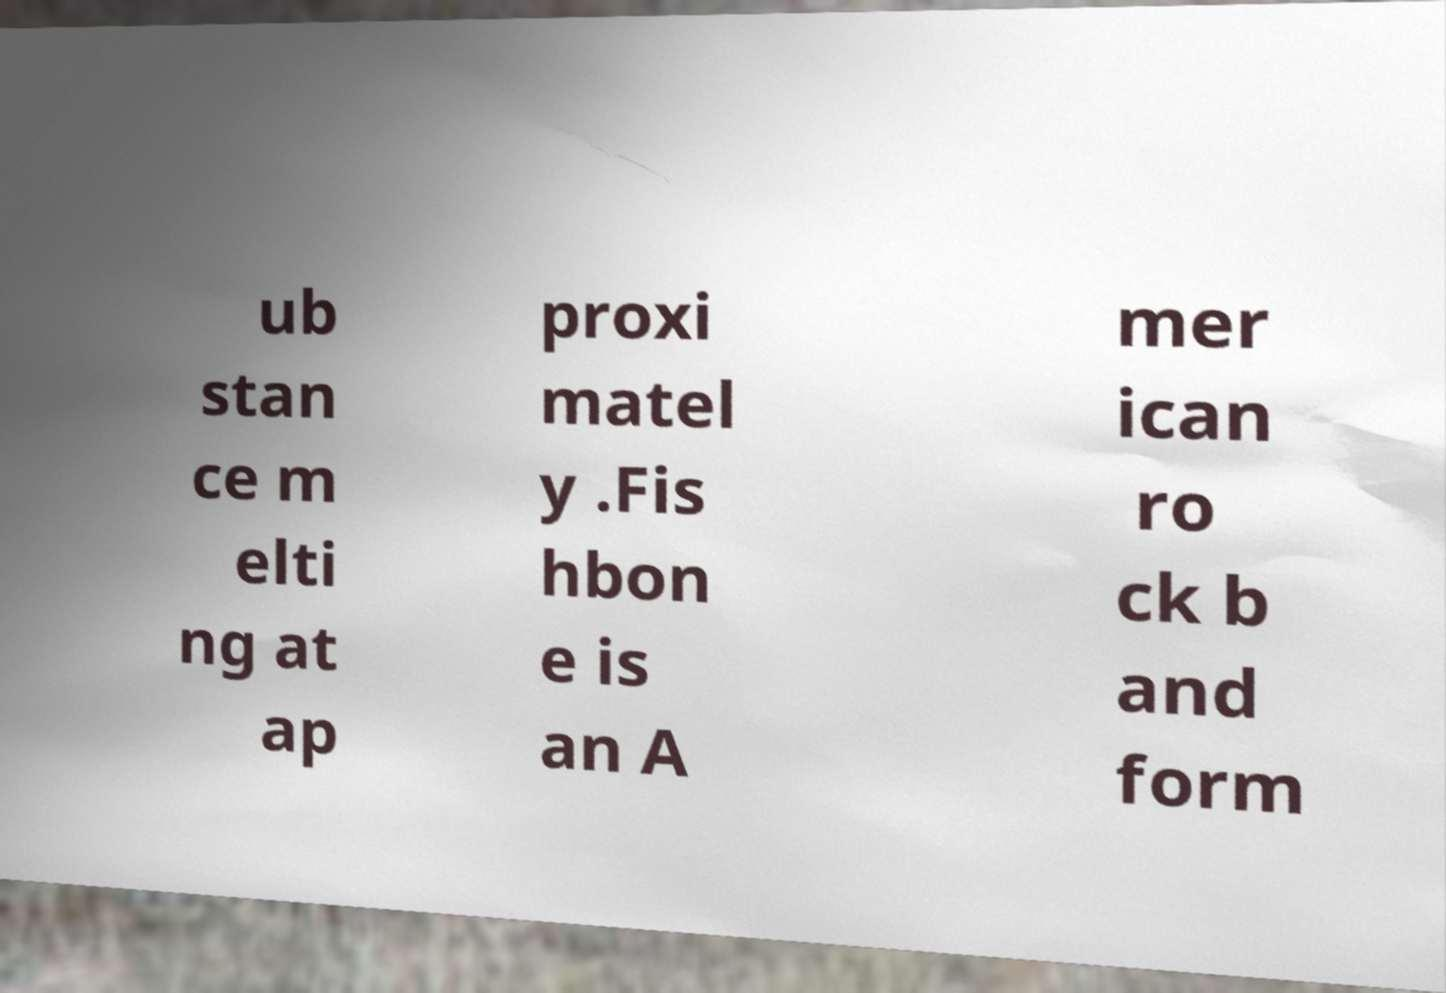What messages or text are displayed in this image? I need them in a readable, typed format. ub stan ce m elti ng at ap proxi matel y .Fis hbon e is an A mer ican ro ck b and form 